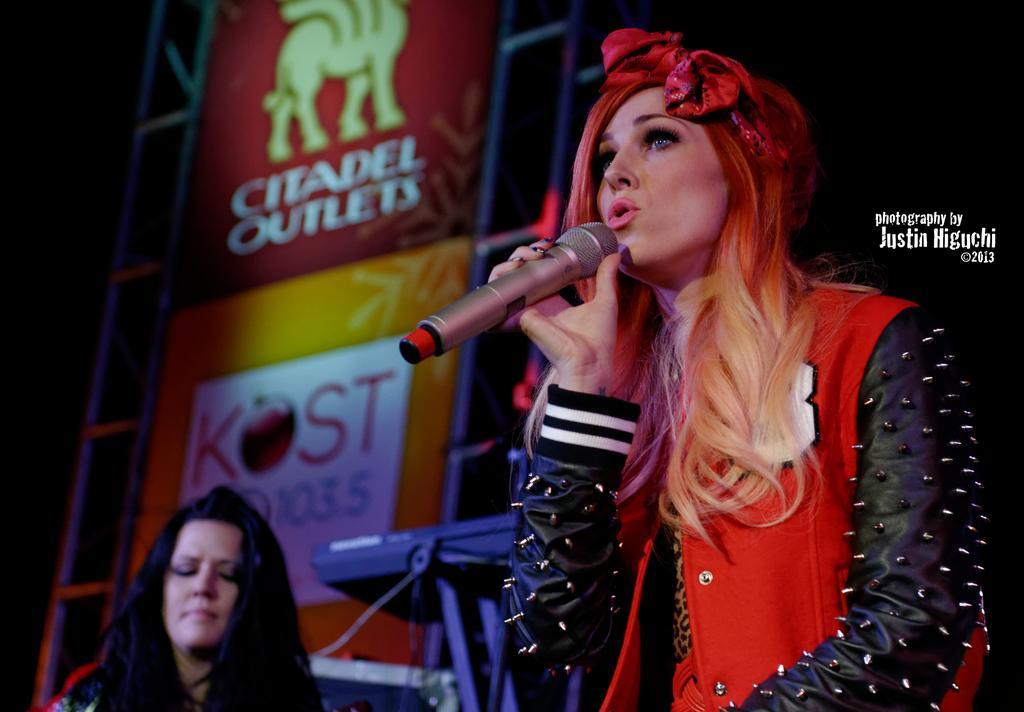In one or two sentences, can you explain what this image depicts? A woman wearing a red and black dress also a hair band is hold a mic and singing. There is a keyboard in the background. Also there is a banner and stands. And a lady is over there. 